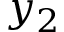<formula> <loc_0><loc_0><loc_500><loc_500>y _ { 2 }</formula> 